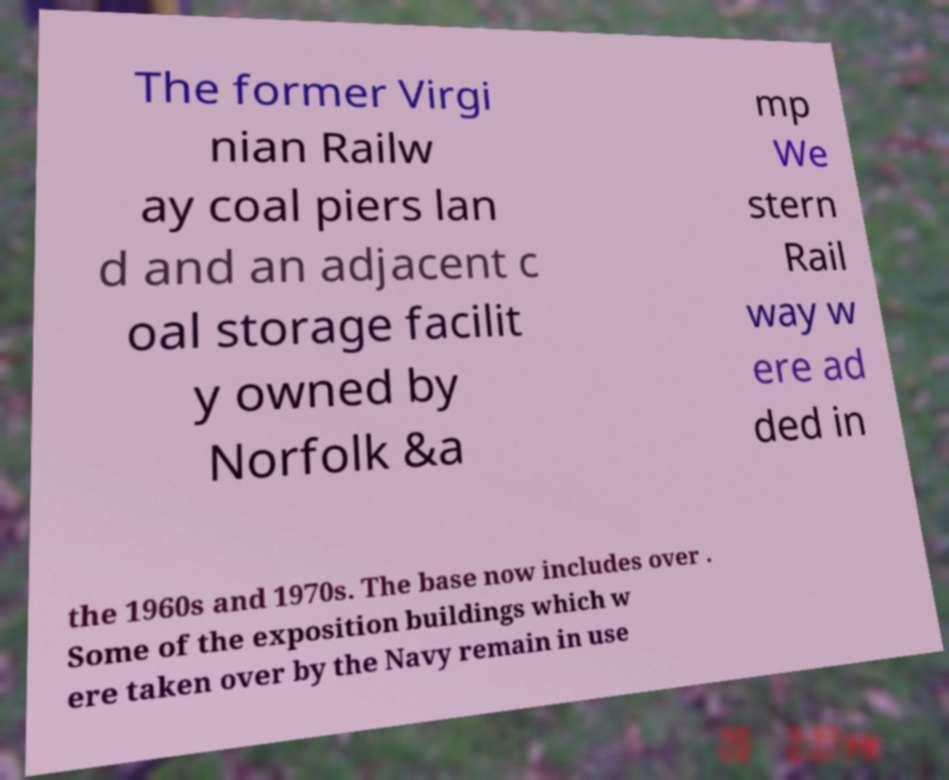What messages or text are displayed in this image? I need them in a readable, typed format. The former Virgi nian Railw ay coal piers lan d and an adjacent c oal storage facilit y owned by Norfolk &a mp We stern Rail way w ere ad ded in the 1960s and 1970s. The base now includes over . Some of the exposition buildings which w ere taken over by the Navy remain in use 